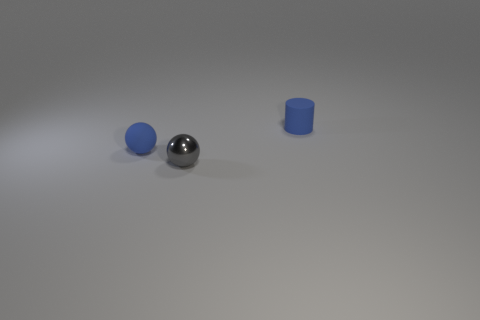What imaginative story could you create involving these objects? In a realm not so different from ours, the gray cube, blue sphere, and blue cylinder are ancient relics of the Elemental Shapes. The cube embodies the earth's steadfast nature, the sphere channels the fluidity of water, and the cylinder symbolizes the air's ability to uplift and spiral. They are brought together by a seeker of wisdom, who believes that when aligned under the cosmic light, the relics will unlock a portal to a dimension of enlightenment and endless discovery. 